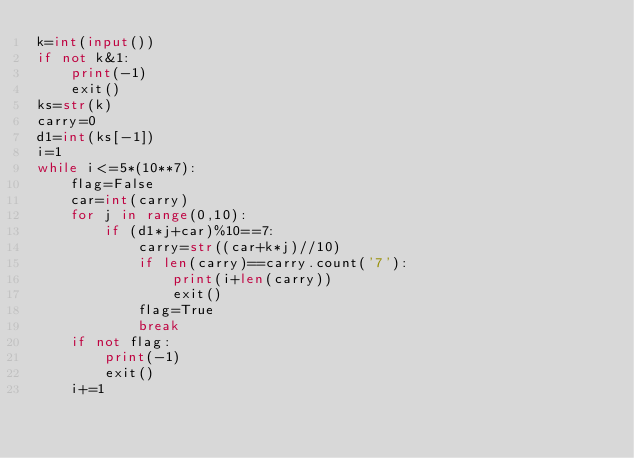<code> <loc_0><loc_0><loc_500><loc_500><_Python_>k=int(input())
if not k&1:
    print(-1)
    exit()
ks=str(k)
carry=0
d1=int(ks[-1])
i=1
while i<=5*(10**7):
    flag=False
    car=int(carry)
    for j in range(0,10):
        if (d1*j+car)%10==7:
            carry=str((car+k*j)//10)
            if len(carry)==carry.count('7'):
                print(i+len(carry))
                exit()
            flag=True
            break
    if not flag:
        print(-1)
        exit()
    i+=1</code> 